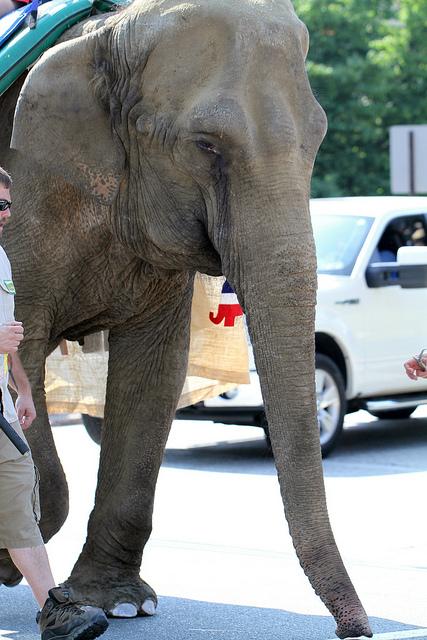Which foot does the man have forward?
Short answer required. Left. What is the color of the car?
Be succinct. White. Is this an elephant?
Give a very brief answer. Yes. 